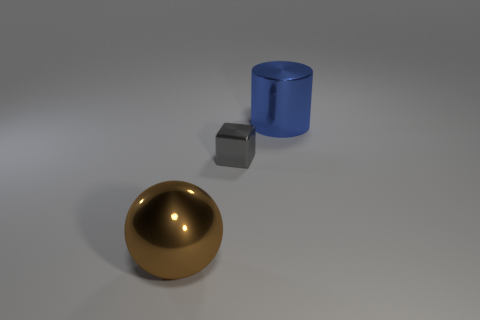What is the relative positioning of the objects? In the image, the bronze sphere is in the foreground on the left, the silver cube is in the middle, and the blue cylinder is in the back slightly to the right. The sphere and cylinder are larger than the cube, indicating they might be closer or larger in size. 